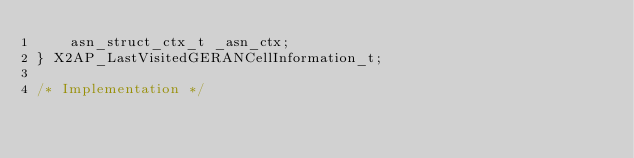Convert code to text. <code><loc_0><loc_0><loc_500><loc_500><_C_>	asn_struct_ctx_t _asn_ctx;
} X2AP_LastVisitedGERANCellInformation_t;

/* Implementation */</code> 